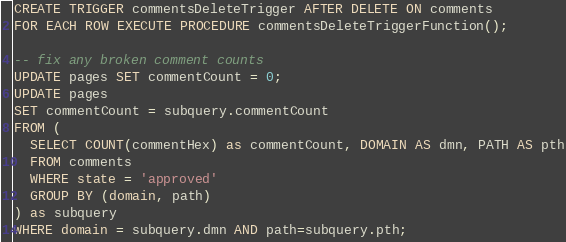Convert code to text. <code><loc_0><loc_0><loc_500><loc_500><_SQL_>CREATE TRIGGER commentsDeleteTrigger AFTER DELETE ON comments
FOR EACH ROW EXECUTE PROCEDURE commentsDeleteTriggerFunction();

-- fix any broken comment counts
UPDATE pages SET commentCount = 0;
UPDATE pages
SET commentCount = subquery.commentCount
FROM (
  SELECT COUNT(commentHex) as commentCount, DOMAIN AS dmn, PATH AS pth
  FROM comments
  WHERE state = 'approved'
  GROUP BY (domain, path)
) as subquery
WHERE domain = subquery.dmn AND path=subquery.pth;</code> 